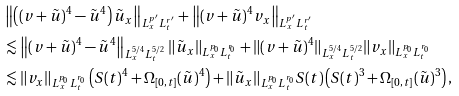Convert formula to latex. <formula><loc_0><loc_0><loc_500><loc_500>& \left \| \left ( ( v + \tilde { u } ) ^ { 4 } - \tilde { u } ^ { 4 } \right ) \tilde { u } _ { x } \right \| _ { L ^ { p ^ { \prime } } _ { x } L ^ { r ^ { \prime } } _ { t } } + \left \| ( v + \tilde { u } ) ^ { 4 } v _ { x } \right \| _ { L ^ { p ^ { \prime } } _ { x } L ^ { r ^ { \prime } } _ { t } } \\ & \lesssim \left \| ( v + \tilde { u } ) ^ { 4 } - \tilde { u } ^ { 4 } \right \| _ { L ^ { 5 / 4 } _ { x } L ^ { 5 / 2 } _ { t } } \| \tilde { u } _ { x } \| _ { L ^ { p _ { 0 } } _ { x } L ^ { r _ { 0 } } _ { t } } + \| ( v + \tilde { u } ) ^ { 4 } \| _ { L ^ { 5 / 4 } _ { x } L ^ { 5 / 2 } _ { t } } \| v _ { x } \| _ { L ^ { p _ { 0 } } _ { x } L ^ { r _ { 0 } } _ { t } } \\ & \lesssim \| v _ { x } \| _ { L ^ { p _ { 0 } } _ { x } L ^ { r _ { 0 } } _ { t } } \left ( S ( t ) ^ { 4 } + \Omega _ { [ 0 , t ] } ( \tilde { u } ) ^ { 4 } \right ) + \| \tilde { u } _ { x } \| _ { L ^ { p _ { 0 } } _ { x } L ^ { r _ { 0 } } _ { t } } S ( t ) \left ( S ( t ) ^ { 3 } + \Omega _ { [ 0 , t ] } ( \tilde { u } ) ^ { 3 } \right ) ,</formula> 